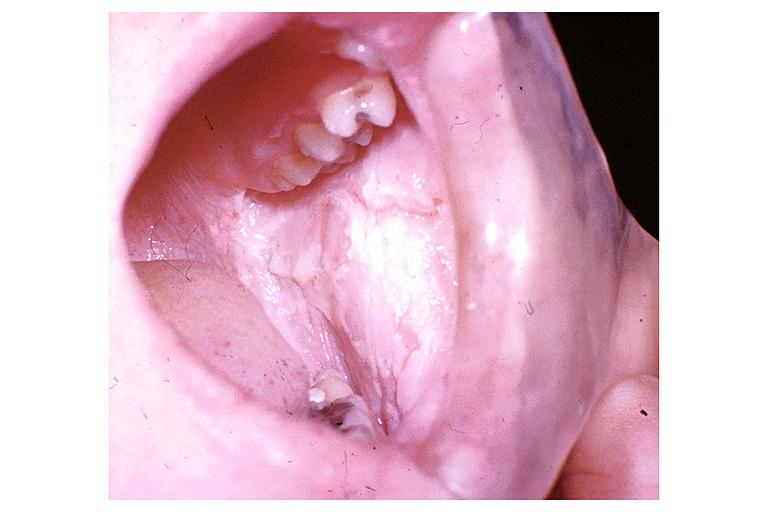where is this?
Answer the question using a single word or phrase. Oral 